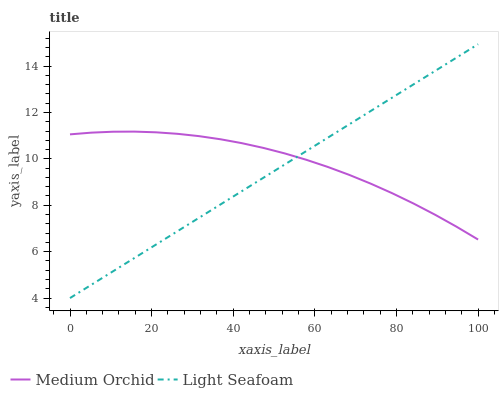Does Light Seafoam have the minimum area under the curve?
Answer yes or no. Yes. Does Medium Orchid have the maximum area under the curve?
Answer yes or no. Yes. Does Light Seafoam have the maximum area under the curve?
Answer yes or no. No. Is Light Seafoam the smoothest?
Answer yes or no. Yes. Is Medium Orchid the roughest?
Answer yes or no. Yes. Is Light Seafoam the roughest?
Answer yes or no. No. Does Light Seafoam have the lowest value?
Answer yes or no. Yes. Does Light Seafoam have the highest value?
Answer yes or no. Yes. Does Light Seafoam intersect Medium Orchid?
Answer yes or no. Yes. Is Light Seafoam less than Medium Orchid?
Answer yes or no. No. Is Light Seafoam greater than Medium Orchid?
Answer yes or no. No. 